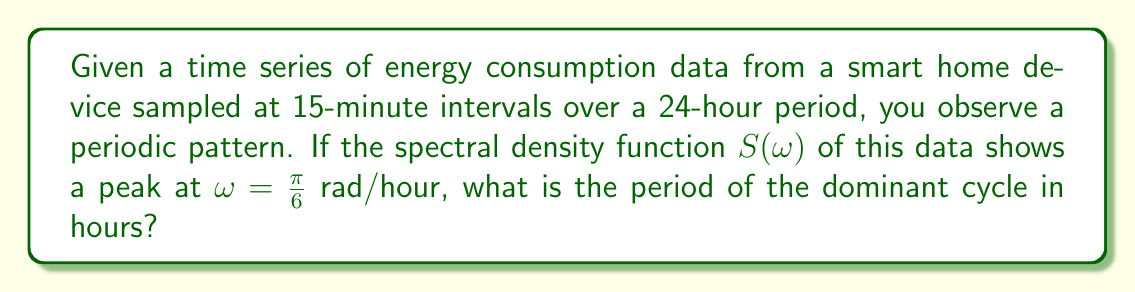Can you answer this question? To solve this problem, we need to understand the relationship between angular frequency $\omega$ and period $T$. Let's approach this step-by-step:

1) The general relationship between angular frequency $\omega$ and frequency $f$ is:
   $$\omega = 2\pi f$$

2) The relationship between frequency $f$ and period $T$ is:
   $$f = \frac{1}{T}$$

3) Combining these, we get:
   $$\omega = \frac{2\pi}{T}$$

4) In our case, we're given that $\omega = \frac{\pi}{6}$ rad/hour. Let's substitute this into our equation:
   $$\frac{\pi}{6} = \frac{2\pi}{T}$$

5) Now, let's solve for $T$:
   $$T = \frac{2\pi}{\frac{\pi}{6}} = 2\pi \cdot \frac{6}{\pi} = 12$$

6) Therefore, the period $T$ is 12 hours.

This makes sense in the context of smart home energy consumption, as it could represent a half-day cycle (e.g., day vs. night energy usage patterns).
Answer: 12 hours 